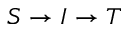<formula> <loc_0><loc_0><loc_500><loc_500>S \rightarrow I \rightarrow T</formula> 